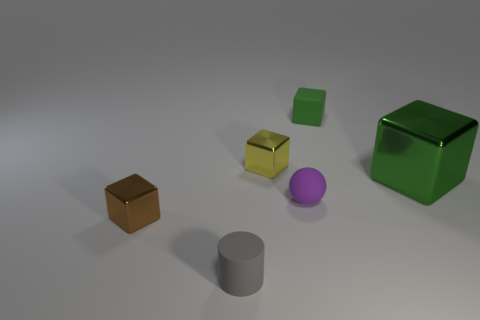Is the number of big purple cubes greater than the number of small gray matte cylinders?
Your response must be concise. No. What material is the yellow cube?
Provide a succinct answer. Metal. There is a matte thing in front of the brown shiny block; is its size the same as the green rubber object?
Ensure brevity in your answer.  Yes. There is a shiny cube in front of the large thing; what size is it?
Provide a succinct answer. Small. Is there anything else that has the same material as the tiny cylinder?
Your answer should be very brief. Yes. How many large yellow metal things are there?
Provide a short and direct response. 0. Is the color of the small matte block the same as the big block?
Ensure brevity in your answer.  Yes. The object that is on the left side of the large green metal block and to the right of the small matte sphere is what color?
Make the answer very short. Green. Are there any tiny purple rubber objects left of the small purple ball?
Give a very brief answer. No. There is a shiny block that is on the right side of the matte block; what number of tiny metallic cubes are behind it?
Your response must be concise. 1. 